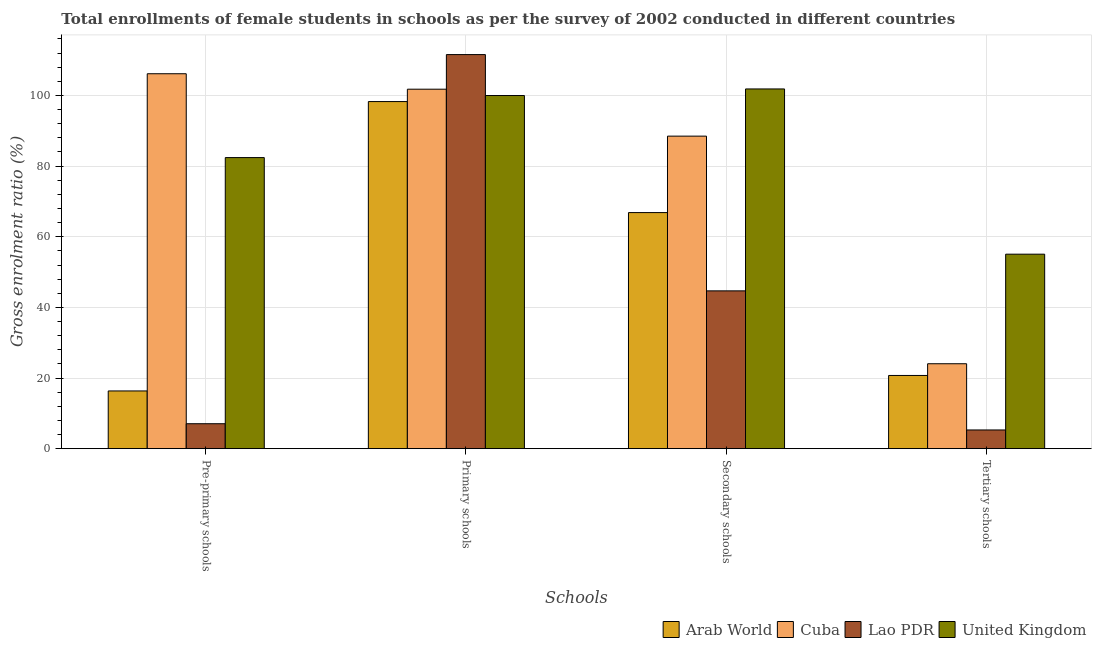How many different coloured bars are there?
Your response must be concise. 4. How many groups of bars are there?
Give a very brief answer. 4. Are the number of bars per tick equal to the number of legend labels?
Keep it short and to the point. Yes. How many bars are there on the 2nd tick from the right?
Offer a terse response. 4. What is the label of the 1st group of bars from the left?
Your answer should be compact. Pre-primary schools. What is the gross enrolment ratio(female) in primary schools in United Kingdom?
Provide a succinct answer. 99.99. Across all countries, what is the maximum gross enrolment ratio(female) in secondary schools?
Offer a very short reply. 101.85. Across all countries, what is the minimum gross enrolment ratio(female) in tertiary schools?
Offer a very short reply. 5.3. In which country was the gross enrolment ratio(female) in pre-primary schools maximum?
Make the answer very short. Cuba. In which country was the gross enrolment ratio(female) in pre-primary schools minimum?
Your answer should be very brief. Lao PDR. What is the total gross enrolment ratio(female) in tertiary schools in the graph?
Your answer should be very brief. 105.14. What is the difference between the gross enrolment ratio(female) in primary schools in United Kingdom and that in Cuba?
Ensure brevity in your answer.  -1.79. What is the difference between the gross enrolment ratio(female) in primary schools in Lao PDR and the gross enrolment ratio(female) in secondary schools in Arab World?
Give a very brief answer. 44.74. What is the average gross enrolment ratio(female) in tertiary schools per country?
Your response must be concise. 26.28. What is the difference between the gross enrolment ratio(female) in pre-primary schools and gross enrolment ratio(female) in primary schools in Lao PDR?
Give a very brief answer. -104.51. What is the ratio of the gross enrolment ratio(female) in primary schools in Cuba to that in Lao PDR?
Give a very brief answer. 0.91. Is the gross enrolment ratio(female) in secondary schools in Arab World less than that in Cuba?
Your answer should be compact. Yes. What is the difference between the highest and the second highest gross enrolment ratio(female) in secondary schools?
Keep it short and to the point. 13.36. What is the difference between the highest and the lowest gross enrolment ratio(female) in tertiary schools?
Ensure brevity in your answer.  49.77. Is it the case that in every country, the sum of the gross enrolment ratio(female) in pre-primary schools and gross enrolment ratio(female) in tertiary schools is greater than the sum of gross enrolment ratio(female) in primary schools and gross enrolment ratio(female) in secondary schools?
Your answer should be very brief. No. What does the 1st bar from the left in Secondary schools represents?
Your answer should be very brief. Arab World. What does the 2nd bar from the right in Secondary schools represents?
Provide a succinct answer. Lao PDR. Is it the case that in every country, the sum of the gross enrolment ratio(female) in pre-primary schools and gross enrolment ratio(female) in primary schools is greater than the gross enrolment ratio(female) in secondary schools?
Keep it short and to the point. Yes. How many bars are there?
Your answer should be very brief. 16. How many countries are there in the graph?
Provide a succinct answer. 4. Are the values on the major ticks of Y-axis written in scientific E-notation?
Your response must be concise. No. Does the graph contain grids?
Give a very brief answer. Yes. Where does the legend appear in the graph?
Your answer should be compact. Bottom right. How many legend labels are there?
Your answer should be compact. 4. What is the title of the graph?
Offer a very short reply. Total enrollments of female students in schools as per the survey of 2002 conducted in different countries. What is the label or title of the X-axis?
Provide a short and direct response. Schools. What is the Gross enrolment ratio (%) in Arab World in Pre-primary schools?
Offer a terse response. 16.34. What is the Gross enrolment ratio (%) of Cuba in Pre-primary schools?
Offer a terse response. 106.15. What is the Gross enrolment ratio (%) of Lao PDR in Pre-primary schools?
Your response must be concise. 7.07. What is the Gross enrolment ratio (%) in United Kingdom in Pre-primary schools?
Your response must be concise. 82.41. What is the Gross enrolment ratio (%) in Arab World in Primary schools?
Keep it short and to the point. 98.28. What is the Gross enrolment ratio (%) in Cuba in Primary schools?
Give a very brief answer. 101.78. What is the Gross enrolment ratio (%) of Lao PDR in Primary schools?
Make the answer very short. 111.58. What is the Gross enrolment ratio (%) of United Kingdom in Primary schools?
Your response must be concise. 99.99. What is the Gross enrolment ratio (%) in Arab World in Secondary schools?
Ensure brevity in your answer.  66.84. What is the Gross enrolment ratio (%) of Cuba in Secondary schools?
Give a very brief answer. 88.49. What is the Gross enrolment ratio (%) in Lao PDR in Secondary schools?
Ensure brevity in your answer.  44.68. What is the Gross enrolment ratio (%) in United Kingdom in Secondary schools?
Your response must be concise. 101.85. What is the Gross enrolment ratio (%) of Arab World in Tertiary schools?
Your answer should be compact. 20.73. What is the Gross enrolment ratio (%) of Cuba in Tertiary schools?
Ensure brevity in your answer.  24.05. What is the Gross enrolment ratio (%) of Lao PDR in Tertiary schools?
Keep it short and to the point. 5.3. What is the Gross enrolment ratio (%) of United Kingdom in Tertiary schools?
Keep it short and to the point. 55.07. Across all Schools, what is the maximum Gross enrolment ratio (%) in Arab World?
Ensure brevity in your answer.  98.28. Across all Schools, what is the maximum Gross enrolment ratio (%) of Cuba?
Make the answer very short. 106.15. Across all Schools, what is the maximum Gross enrolment ratio (%) in Lao PDR?
Give a very brief answer. 111.58. Across all Schools, what is the maximum Gross enrolment ratio (%) of United Kingdom?
Your answer should be compact. 101.85. Across all Schools, what is the minimum Gross enrolment ratio (%) of Arab World?
Offer a terse response. 16.34. Across all Schools, what is the minimum Gross enrolment ratio (%) in Cuba?
Keep it short and to the point. 24.05. Across all Schools, what is the minimum Gross enrolment ratio (%) of Lao PDR?
Ensure brevity in your answer.  5.3. Across all Schools, what is the minimum Gross enrolment ratio (%) in United Kingdom?
Provide a succinct answer. 55.07. What is the total Gross enrolment ratio (%) in Arab World in the graph?
Give a very brief answer. 202.19. What is the total Gross enrolment ratio (%) in Cuba in the graph?
Offer a terse response. 320.47. What is the total Gross enrolment ratio (%) in Lao PDR in the graph?
Keep it short and to the point. 168.63. What is the total Gross enrolment ratio (%) of United Kingdom in the graph?
Provide a short and direct response. 339.32. What is the difference between the Gross enrolment ratio (%) of Arab World in Pre-primary schools and that in Primary schools?
Offer a very short reply. -81.93. What is the difference between the Gross enrolment ratio (%) of Cuba in Pre-primary schools and that in Primary schools?
Make the answer very short. 4.38. What is the difference between the Gross enrolment ratio (%) in Lao PDR in Pre-primary schools and that in Primary schools?
Offer a very short reply. -104.51. What is the difference between the Gross enrolment ratio (%) in United Kingdom in Pre-primary schools and that in Primary schools?
Your answer should be very brief. -17.57. What is the difference between the Gross enrolment ratio (%) in Arab World in Pre-primary schools and that in Secondary schools?
Your answer should be compact. -50.5. What is the difference between the Gross enrolment ratio (%) in Cuba in Pre-primary schools and that in Secondary schools?
Provide a short and direct response. 17.67. What is the difference between the Gross enrolment ratio (%) of Lao PDR in Pre-primary schools and that in Secondary schools?
Offer a very short reply. -37.62. What is the difference between the Gross enrolment ratio (%) in United Kingdom in Pre-primary schools and that in Secondary schools?
Make the answer very short. -19.44. What is the difference between the Gross enrolment ratio (%) of Arab World in Pre-primary schools and that in Tertiary schools?
Your response must be concise. -4.38. What is the difference between the Gross enrolment ratio (%) in Cuba in Pre-primary schools and that in Tertiary schools?
Keep it short and to the point. 82.11. What is the difference between the Gross enrolment ratio (%) in Lao PDR in Pre-primary schools and that in Tertiary schools?
Provide a succinct answer. 1.77. What is the difference between the Gross enrolment ratio (%) of United Kingdom in Pre-primary schools and that in Tertiary schools?
Give a very brief answer. 27.35. What is the difference between the Gross enrolment ratio (%) of Arab World in Primary schools and that in Secondary schools?
Keep it short and to the point. 31.43. What is the difference between the Gross enrolment ratio (%) of Cuba in Primary schools and that in Secondary schools?
Provide a short and direct response. 13.29. What is the difference between the Gross enrolment ratio (%) of Lao PDR in Primary schools and that in Secondary schools?
Provide a succinct answer. 66.9. What is the difference between the Gross enrolment ratio (%) in United Kingdom in Primary schools and that in Secondary schools?
Keep it short and to the point. -1.86. What is the difference between the Gross enrolment ratio (%) of Arab World in Primary schools and that in Tertiary schools?
Give a very brief answer. 77.55. What is the difference between the Gross enrolment ratio (%) of Cuba in Primary schools and that in Tertiary schools?
Your response must be concise. 77.73. What is the difference between the Gross enrolment ratio (%) of Lao PDR in Primary schools and that in Tertiary schools?
Your answer should be compact. 106.28. What is the difference between the Gross enrolment ratio (%) of United Kingdom in Primary schools and that in Tertiary schools?
Offer a terse response. 44.92. What is the difference between the Gross enrolment ratio (%) of Arab World in Secondary schools and that in Tertiary schools?
Provide a short and direct response. 46.12. What is the difference between the Gross enrolment ratio (%) in Cuba in Secondary schools and that in Tertiary schools?
Your answer should be very brief. 64.44. What is the difference between the Gross enrolment ratio (%) of Lao PDR in Secondary schools and that in Tertiary schools?
Keep it short and to the point. 39.38. What is the difference between the Gross enrolment ratio (%) in United Kingdom in Secondary schools and that in Tertiary schools?
Ensure brevity in your answer.  46.78. What is the difference between the Gross enrolment ratio (%) of Arab World in Pre-primary schools and the Gross enrolment ratio (%) of Cuba in Primary schools?
Your response must be concise. -85.44. What is the difference between the Gross enrolment ratio (%) in Arab World in Pre-primary schools and the Gross enrolment ratio (%) in Lao PDR in Primary schools?
Your answer should be very brief. -95.23. What is the difference between the Gross enrolment ratio (%) of Arab World in Pre-primary schools and the Gross enrolment ratio (%) of United Kingdom in Primary schools?
Your response must be concise. -83.64. What is the difference between the Gross enrolment ratio (%) of Cuba in Pre-primary schools and the Gross enrolment ratio (%) of Lao PDR in Primary schools?
Your response must be concise. -5.42. What is the difference between the Gross enrolment ratio (%) in Cuba in Pre-primary schools and the Gross enrolment ratio (%) in United Kingdom in Primary schools?
Your answer should be compact. 6.17. What is the difference between the Gross enrolment ratio (%) of Lao PDR in Pre-primary schools and the Gross enrolment ratio (%) of United Kingdom in Primary schools?
Make the answer very short. -92.92. What is the difference between the Gross enrolment ratio (%) of Arab World in Pre-primary schools and the Gross enrolment ratio (%) of Cuba in Secondary schools?
Offer a very short reply. -72.14. What is the difference between the Gross enrolment ratio (%) of Arab World in Pre-primary schools and the Gross enrolment ratio (%) of Lao PDR in Secondary schools?
Make the answer very short. -28.34. What is the difference between the Gross enrolment ratio (%) in Arab World in Pre-primary schools and the Gross enrolment ratio (%) in United Kingdom in Secondary schools?
Offer a very short reply. -85.51. What is the difference between the Gross enrolment ratio (%) in Cuba in Pre-primary schools and the Gross enrolment ratio (%) in Lao PDR in Secondary schools?
Keep it short and to the point. 61.47. What is the difference between the Gross enrolment ratio (%) in Cuba in Pre-primary schools and the Gross enrolment ratio (%) in United Kingdom in Secondary schools?
Provide a short and direct response. 4.31. What is the difference between the Gross enrolment ratio (%) in Lao PDR in Pre-primary schools and the Gross enrolment ratio (%) in United Kingdom in Secondary schools?
Your answer should be compact. -94.78. What is the difference between the Gross enrolment ratio (%) in Arab World in Pre-primary schools and the Gross enrolment ratio (%) in Cuba in Tertiary schools?
Your answer should be very brief. -7.7. What is the difference between the Gross enrolment ratio (%) of Arab World in Pre-primary schools and the Gross enrolment ratio (%) of Lao PDR in Tertiary schools?
Ensure brevity in your answer.  11.04. What is the difference between the Gross enrolment ratio (%) of Arab World in Pre-primary schools and the Gross enrolment ratio (%) of United Kingdom in Tertiary schools?
Give a very brief answer. -38.72. What is the difference between the Gross enrolment ratio (%) of Cuba in Pre-primary schools and the Gross enrolment ratio (%) of Lao PDR in Tertiary schools?
Your answer should be compact. 100.85. What is the difference between the Gross enrolment ratio (%) in Cuba in Pre-primary schools and the Gross enrolment ratio (%) in United Kingdom in Tertiary schools?
Your answer should be very brief. 51.09. What is the difference between the Gross enrolment ratio (%) in Lao PDR in Pre-primary schools and the Gross enrolment ratio (%) in United Kingdom in Tertiary schools?
Your response must be concise. -48. What is the difference between the Gross enrolment ratio (%) in Arab World in Primary schools and the Gross enrolment ratio (%) in Cuba in Secondary schools?
Your answer should be very brief. 9.79. What is the difference between the Gross enrolment ratio (%) of Arab World in Primary schools and the Gross enrolment ratio (%) of Lao PDR in Secondary schools?
Offer a terse response. 53.6. What is the difference between the Gross enrolment ratio (%) in Arab World in Primary schools and the Gross enrolment ratio (%) in United Kingdom in Secondary schools?
Your answer should be compact. -3.57. What is the difference between the Gross enrolment ratio (%) of Cuba in Primary schools and the Gross enrolment ratio (%) of Lao PDR in Secondary schools?
Give a very brief answer. 57.1. What is the difference between the Gross enrolment ratio (%) of Cuba in Primary schools and the Gross enrolment ratio (%) of United Kingdom in Secondary schools?
Offer a terse response. -0.07. What is the difference between the Gross enrolment ratio (%) in Lao PDR in Primary schools and the Gross enrolment ratio (%) in United Kingdom in Secondary schools?
Provide a short and direct response. 9.73. What is the difference between the Gross enrolment ratio (%) in Arab World in Primary schools and the Gross enrolment ratio (%) in Cuba in Tertiary schools?
Give a very brief answer. 74.23. What is the difference between the Gross enrolment ratio (%) in Arab World in Primary schools and the Gross enrolment ratio (%) in Lao PDR in Tertiary schools?
Offer a terse response. 92.98. What is the difference between the Gross enrolment ratio (%) of Arab World in Primary schools and the Gross enrolment ratio (%) of United Kingdom in Tertiary schools?
Your answer should be very brief. 43.21. What is the difference between the Gross enrolment ratio (%) in Cuba in Primary schools and the Gross enrolment ratio (%) in Lao PDR in Tertiary schools?
Provide a succinct answer. 96.48. What is the difference between the Gross enrolment ratio (%) in Cuba in Primary schools and the Gross enrolment ratio (%) in United Kingdom in Tertiary schools?
Your answer should be compact. 46.71. What is the difference between the Gross enrolment ratio (%) in Lao PDR in Primary schools and the Gross enrolment ratio (%) in United Kingdom in Tertiary schools?
Your answer should be compact. 56.51. What is the difference between the Gross enrolment ratio (%) in Arab World in Secondary schools and the Gross enrolment ratio (%) in Cuba in Tertiary schools?
Provide a short and direct response. 42.8. What is the difference between the Gross enrolment ratio (%) in Arab World in Secondary schools and the Gross enrolment ratio (%) in Lao PDR in Tertiary schools?
Your response must be concise. 61.54. What is the difference between the Gross enrolment ratio (%) of Arab World in Secondary schools and the Gross enrolment ratio (%) of United Kingdom in Tertiary schools?
Keep it short and to the point. 11.78. What is the difference between the Gross enrolment ratio (%) in Cuba in Secondary schools and the Gross enrolment ratio (%) in Lao PDR in Tertiary schools?
Give a very brief answer. 83.19. What is the difference between the Gross enrolment ratio (%) in Cuba in Secondary schools and the Gross enrolment ratio (%) in United Kingdom in Tertiary schools?
Provide a succinct answer. 33.42. What is the difference between the Gross enrolment ratio (%) of Lao PDR in Secondary schools and the Gross enrolment ratio (%) of United Kingdom in Tertiary schools?
Provide a short and direct response. -10.38. What is the average Gross enrolment ratio (%) in Arab World per Schools?
Provide a short and direct response. 50.55. What is the average Gross enrolment ratio (%) of Cuba per Schools?
Ensure brevity in your answer.  80.12. What is the average Gross enrolment ratio (%) in Lao PDR per Schools?
Make the answer very short. 42.16. What is the average Gross enrolment ratio (%) in United Kingdom per Schools?
Your answer should be very brief. 84.83. What is the difference between the Gross enrolment ratio (%) of Arab World and Gross enrolment ratio (%) of Cuba in Pre-primary schools?
Make the answer very short. -89.81. What is the difference between the Gross enrolment ratio (%) in Arab World and Gross enrolment ratio (%) in Lao PDR in Pre-primary schools?
Your answer should be compact. 9.28. What is the difference between the Gross enrolment ratio (%) in Arab World and Gross enrolment ratio (%) in United Kingdom in Pre-primary schools?
Make the answer very short. -66.07. What is the difference between the Gross enrolment ratio (%) of Cuba and Gross enrolment ratio (%) of Lao PDR in Pre-primary schools?
Your response must be concise. 99.09. What is the difference between the Gross enrolment ratio (%) of Cuba and Gross enrolment ratio (%) of United Kingdom in Pre-primary schools?
Give a very brief answer. 23.74. What is the difference between the Gross enrolment ratio (%) in Lao PDR and Gross enrolment ratio (%) in United Kingdom in Pre-primary schools?
Keep it short and to the point. -75.35. What is the difference between the Gross enrolment ratio (%) of Arab World and Gross enrolment ratio (%) of Cuba in Primary schools?
Keep it short and to the point. -3.5. What is the difference between the Gross enrolment ratio (%) in Arab World and Gross enrolment ratio (%) in Lao PDR in Primary schools?
Offer a terse response. -13.3. What is the difference between the Gross enrolment ratio (%) in Arab World and Gross enrolment ratio (%) in United Kingdom in Primary schools?
Give a very brief answer. -1.71. What is the difference between the Gross enrolment ratio (%) in Cuba and Gross enrolment ratio (%) in Lao PDR in Primary schools?
Make the answer very short. -9.8. What is the difference between the Gross enrolment ratio (%) in Cuba and Gross enrolment ratio (%) in United Kingdom in Primary schools?
Give a very brief answer. 1.79. What is the difference between the Gross enrolment ratio (%) of Lao PDR and Gross enrolment ratio (%) of United Kingdom in Primary schools?
Keep it short and to the point. 11.59. What is the difference between the Gross enrolment ratio (%) of Arab World and Gross enrolment ratio (%) of Cuba in Secondary schools?
Offer a very short reply. -21.64. What is the difference between the Gross enrolment ratio (%) in Arab World and Gross enrolment ratio (%) in Lao PDR in Secondary schools?
Make the answer very short. 22.16. What is the difference between the Gross enrolment ratio (%) of Arab World and Gross enrolment ratio (%) of United Kingdom in Secondary schools?
Make the answer very short. -35.01. What is the difference between the Gross enrolment ratio (%) in Cuba and Gross enrolment ratio (%) in Lao PDR in Secondary schools?
Offer a very short reply. 43.81. What is the difference between the Gross enrolment ratio (%) in Cuba and Gross enrolment ratio (%) in United Kingdom in Secondary schools?
Keep it short and to the point. -13.36. What is the difference between the Gross enrolment ratio (%) in Lao PDR and Gross enrolment ratio (%) in United Kingdom in Secondary schools?
Your answer should be very brief. -57.17. What is the difference between the Gross enrolment ratio (%) in Arab World and Gross enrolment ratio (%) in Cuba in Tertiary schools?
Your answer should be compact. -3.32. What is the difference between the Gross enrolment ratio (%) in Arab World and Gross enrolment ratio (%) in Lao PDR in Tertiary schools?
Your response must be concise. 15.43. What is the difference between the Gross enrolment ratio (%) of Arab World and Gross enrolment ratio (%) of United Kingdom in Tertiary schools?
Offer a terse response. -34.34. What is the difference between the Gross enrolment ratio (%) of Cuba and Gross enrolment ratio (%) of Lao PDR in Tertiary schools?
Offer a terse response. 18.75. What is the difference between the Gross enrolment ratio (%) in Cuba and Gross enrolment ratio (%) in United Kingdom in Tertiary schools?
Keep it short and to the point. -31.02. What is the difference between the Gross enrolment ratio (%) of Lao PDR and Gross enrolment ratio (%) of United Kingdom in Tertiary schools?
Your answer should be compact. -49.77. What is the ratio of the Gross enrolment ratio (%) of Arab World in Pre-primary schools to that in Primary schools?
Ensure brevity in your answer.  0.17. What is the ratio of the Gross enrolment ratio (%) in Cuba in Pre-primary schools to that in Primary schools?
Your response must be concise. 1.04. What is the ratio of the Gross enrolment ratio (%) of Lao PDR in Pre-primary schools to that in Primary schools?
Give a very brief answer. 0.06. What is the ratio of the Gross enrolment ratio (%) in United Kingdom in Pre-primary schools to that in Primary schools?
Offer a terse response. 0.82. What is the ratio of the Gross enrolment ratio (%) in Arab World in Pre-primary schools to that in Secondary schools?
Provide a short and direct response. 0.24. What is the ratio of the Gross enrolment ratio (%) of Cuba in Pre-primary schools to that in Secondary schools?
Give a very brief answer. 1.2. What is the ratio of the Gross enrolment ratio (%) of Lao PDR in Pre-primary schools to that in Secondary schools?
Provide a succinct answer. 0.16. What is the ratio of the Gross enrolment ratio (%) of United Kingdom in Pre-primary schools to that in Secondary schools?
Your response must be concise. 0.81. What is the ratio of the Gross enrolment ratio (%) in Arab World in Pre-primary schools to that in Tertiary schools?
Your response must be concise. 0.79. What is the ratio of the Gross enrolment ratio (%) in Cuba in Pre-primary schools to that in Tertiary schools?
Make the answer very short. 4.41. What is the ratio of the Gross enrolment ratio (%) in Lao PDR in Pre-primary schools to that in Tertiary schools?
Provide a short and direct response. 1.33. What is the ratio of the Gross enrolment ratio (%) in United Kingdom in Pre-primary schools to that in Tertiary schools?
Provide a succinct answer. 1.5. What is the ratio of the Gross enrolment ratio (%) in Arab World in Primary schools to that in Secondary schools?
Your answer should be very brief. 1.47. What is the ratio of the Gross enrolment ratio (%) in Cuba in Primary schools to that in Secondary schools?
Keep it short and to the point. 1.15. What is the ratio of the Gross enrolment ratio (%) of Lao PDR in Primary schools to that in Secondary schools?
Provide a succinct answer. 2.5. What is the ratio of the Gross enrolment ratio (%) of United Kingdom in Primary schools to that in Secondary schools?
Your answer should be very brief. 0.98. What is the ratio of the Gross enrolment ratio (%) in Arab World in Primary schools to that in Tertiary schools?
Offer a terse response. 4.74. What is the ratio of the Gross enrolment ratio (%) of Cuba in Primary schools to that in Tertiary schools?
Give a very brief answer. 4.23. What is the ratio of the Gross enrolment ratio (%) of Lao PDR in Primary schools to that in Tertiary schools?
Make the answer very short. 21.05. What is the ratio of the Gross enrolment ratio (%) of United Kingdom in Primary schools to that in Tertiary schools?
Offer a very short reply. 1.82. What is the ratio of the Gross enrolment ratio (%) of Arab World in Secondary schools to that in Tertiary schools?
Offer a very short reply. 3.22. What is the ratio of the Gross enrolment ratio (%) in Cuba in Secondary schools to that in Tertiary schools?
Keep it short and to the point. 3.68. What is the ratio of the Gross enrolment ratio (%) in Lao PDR in Secondary schools to that in Tertiary schools?
Give a very brief answer. 8.43. What is the ratio of the Gross enrolment ratio (%) of United Kingdom in Secondary schools to that in Tertiary schools?
Ensure brevity in your answer.  1.85. What is the difference between the highest and the second highest Gross enrolment ratio (%) in Arab World?
Make the answer very short. 31.43. What is the difference between the highest and the second highest Gross enrolment ratio (%) in Cuba?
Keep it short and to the point. 4.38. What is the difference between the highest and the second highest Gross enrolment ratio (%) of Lao PDR?
Your answer should be compact. 66.9. What is the difference between the highest and the second highest Gross enrolment ratio (%) of United Kingdom?
Provide a succinct answer. 1.86. What is the difference between the highest and the lowest Gross enrolment ratio (%) of Arab World?
Provide a succinct answer. 81.93. What is the difference between the highest and the lowest Gross enrolment ratio (%) in Cuba?
Your answer should be very brief. 82.11. What is the difference between the highest and the lowest Gross enrolment ratio (%) of Lao PDR?
Provide a succinct answer. 106.28. What is the difference between the highest and the lowest Gross enrolment ratio (%) of United Kingdom?
Keep it short and to the point. 46.78. 